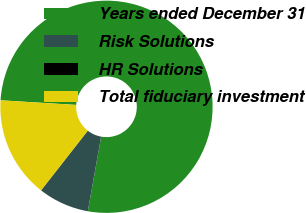<chart> <loc_0><loc_0><loc_500><loc_500><pie_chart><fcel>Years ended December 31<fcel>Risk Solutions<fcel>HR Solutions<fcel>Total fiduciary investment<nl><fcel>76.84%<fcel>7.72%<fcel>0.04%<fcel>15.4%<nl></chart> 